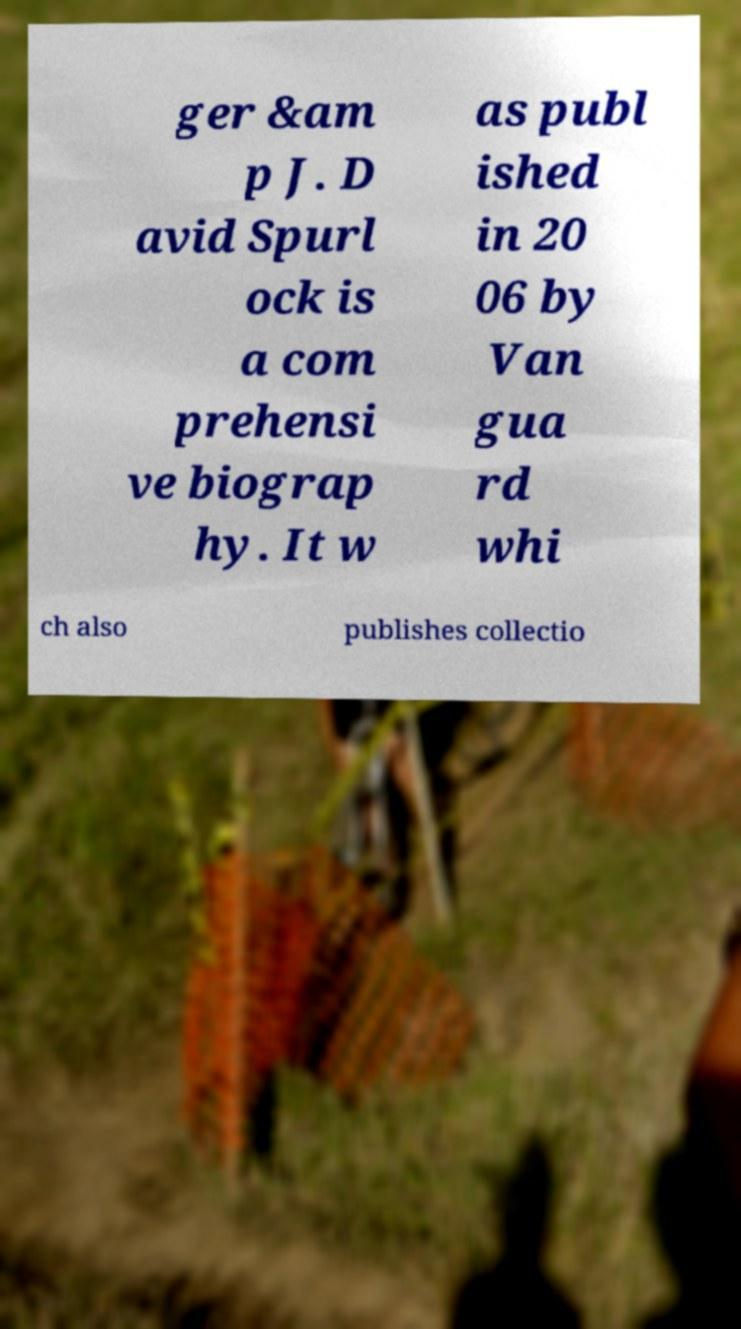I need the written content from this picture converted into text. Can you do that? ger &am p J. D avid Spurl ock is a com prehensi ve biograp hy. It w as publ ished in 20 06 by Van gua rd whi ch also publishes collectio 